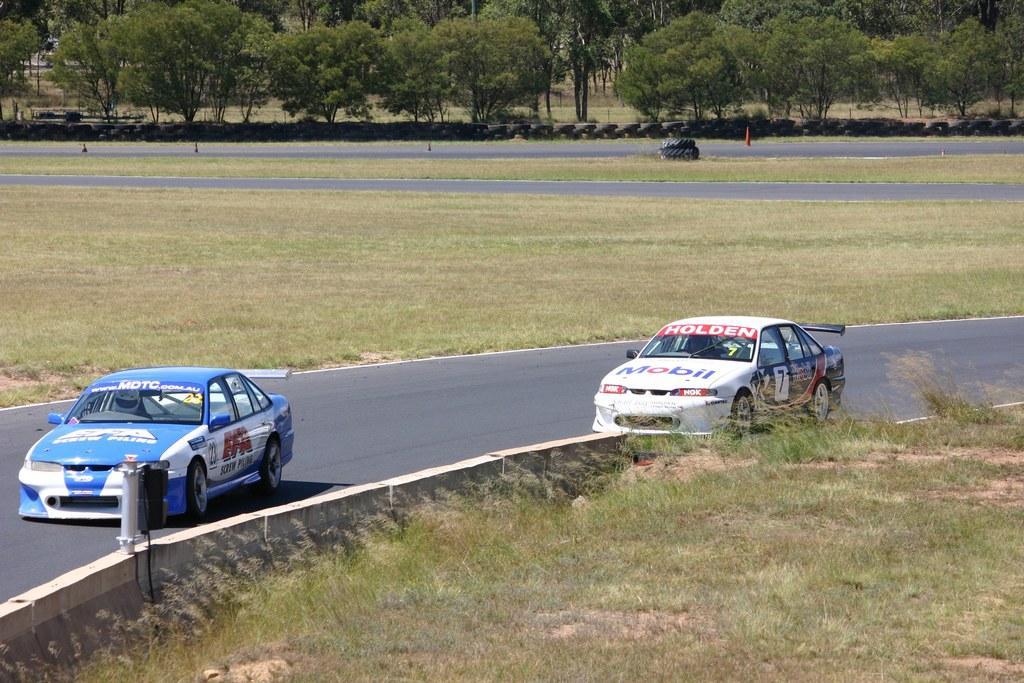Can you describe this image briefly? In this image we can see cars on the road. At the bottom there is grass. In the background there are trees and we can see tires. There are traffic cones. 